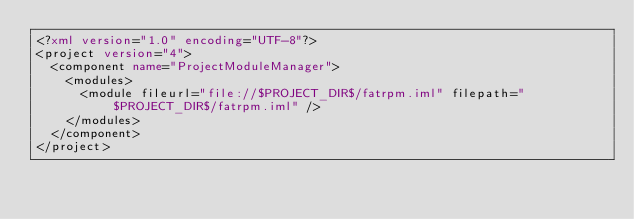<code> <loc_0><loc_0><loc_500><loc_500><_XML_><?xml version="1.0" encoding="UTF-8"?>
<project version="4">
  <component name="ProjectModuleManager">
    <modules>
      <module fileurl="file://$PROJECT_DIR$/fatrpm.iml" filepath="$PROJECT_DIR$/fatrpm.iml" />
    </modules>
  </component>
</project>

</code> 